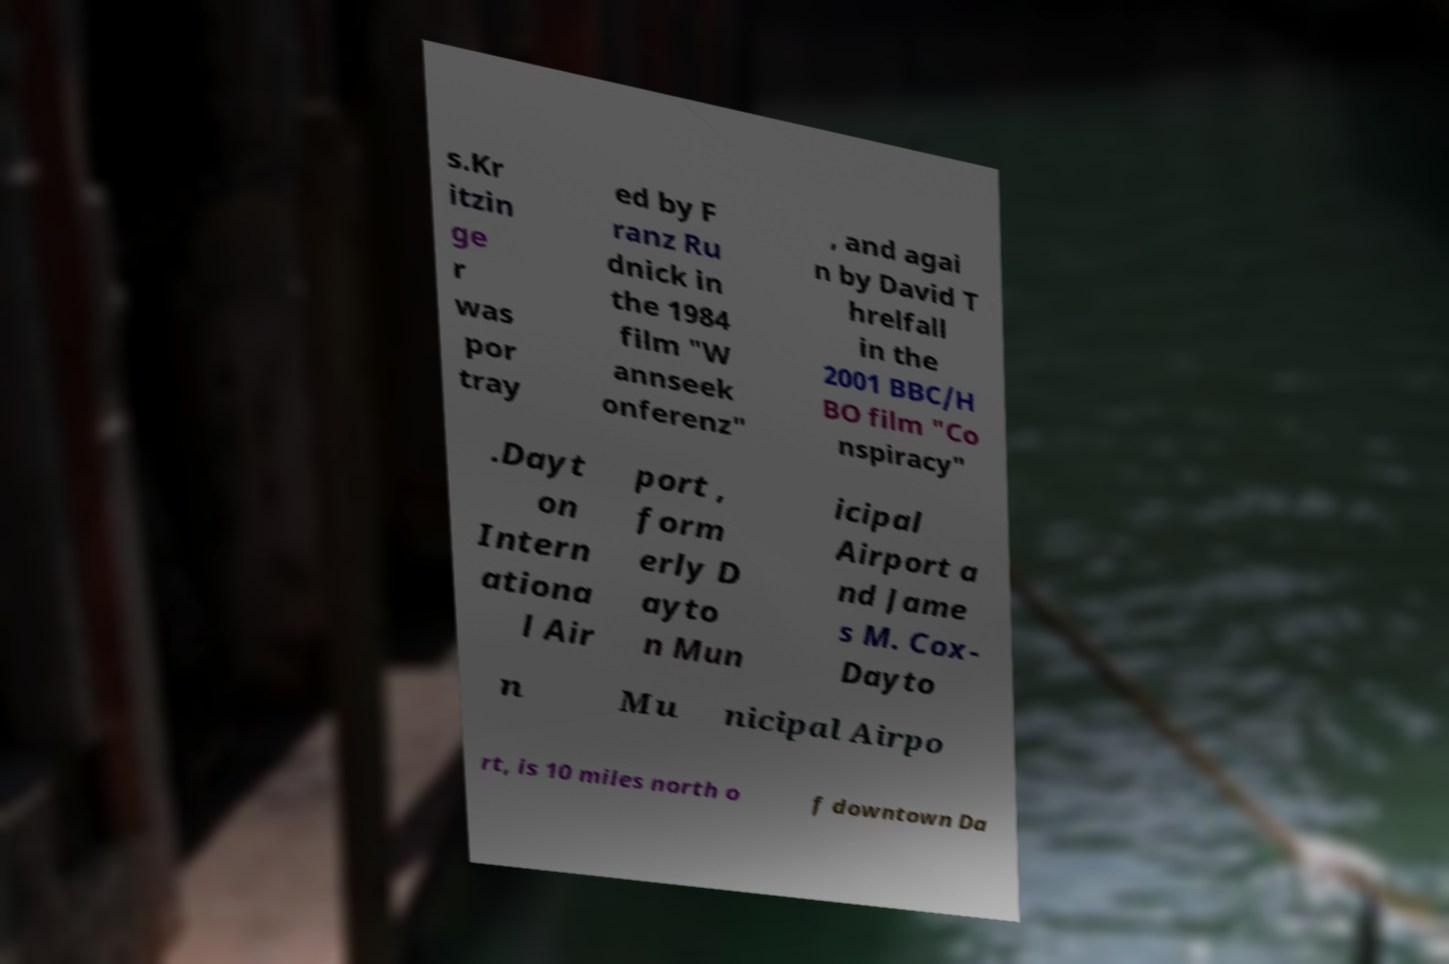There's text embedded in this image that I need extracted. Can you transcribe it verbatim? s.Kr itzin ge r was por tray ed by F ranz Ru dnick in the 1984 film "W annseek onferenz" , and agai n by David T hrelfall in the 2001 BBC/H BO film "Co nspiracy" .Dayt on Intern ationa l Air port , form erly D ayto n Mun icipal Airport a nd Jame s M. Cox- Dayto n Mu nicipal Airpo rt, is 10 miles north o f downtown Da 